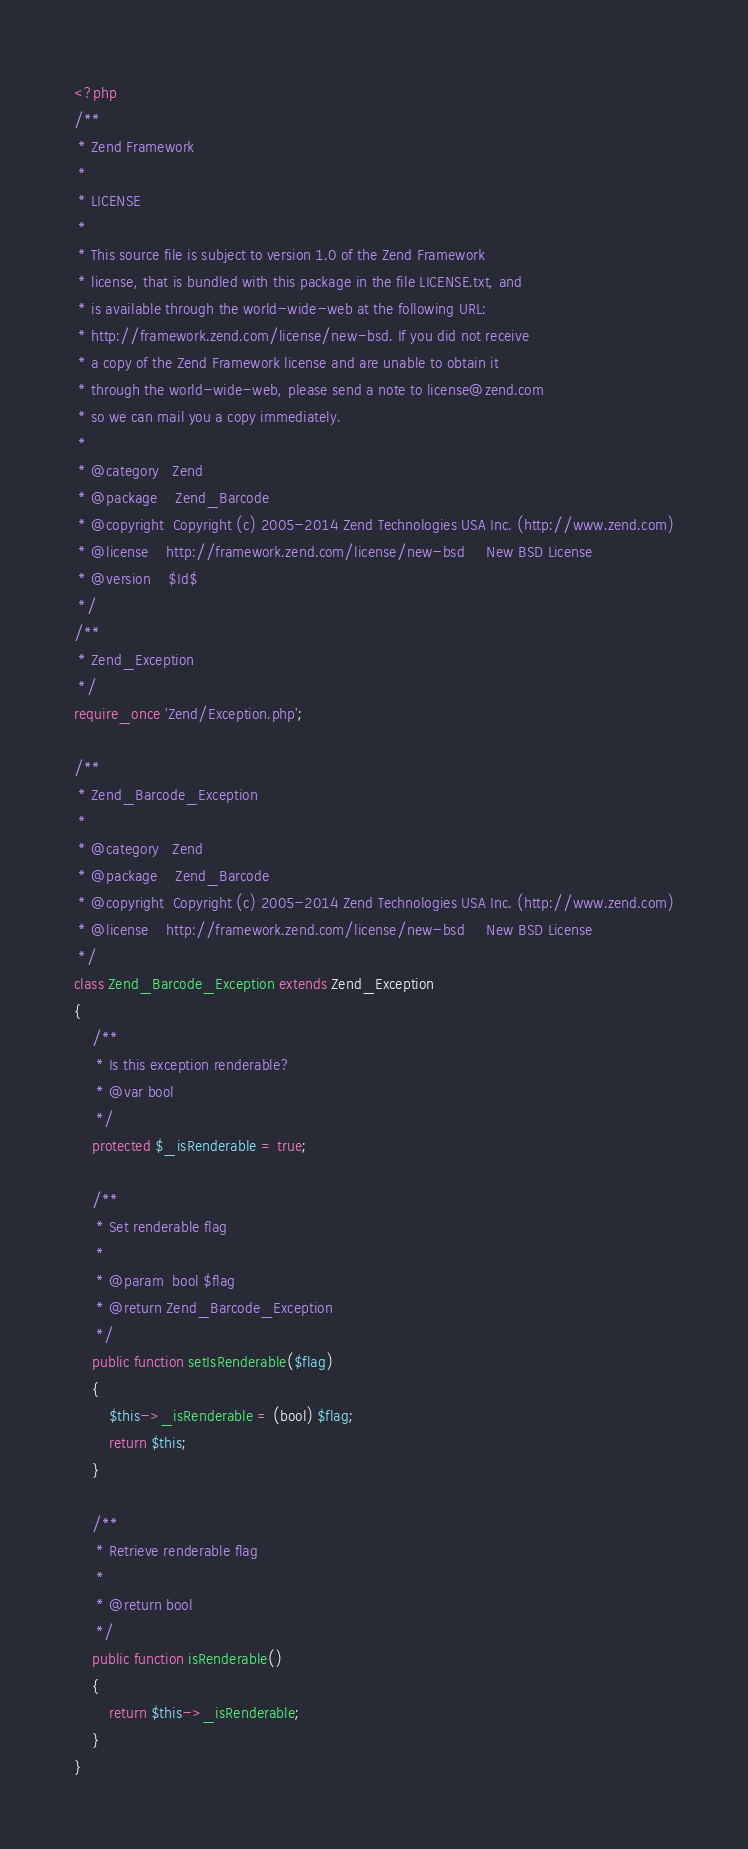Convert code to text. <code><loc_0><loc_0><loc_500><loc_500><_PHP_><?php
/**
 * Zend Framework
 *
 * LICENSE
 *
 * This source file is subject to version 1.0 of the Zend Framework
 * license, that is bundled with this package in the file LICENSE.txt, and
 * is available through the world-wide-web at the following URL:
 * http://framework.zend.com/license/new-bsd. If you did not receive
 * a copy of the Zend Framework license and are unable to obtain it
 * through the world-wide-web, please send a note to license@zend.com
 * so we can mail you a copy immediately.
 *
 * @category   Zend
 * @package    Zend_Barcode
 * @copyright  Copyright (c) 2005-2014 Zend Technologies USA Inc. (http://www.zend.com)
 * @license    http://framework.zend.com/license/new-bsd     New BSD License
 * @version    $Id$
 */
/**
 * Zend_Exception
 */
require_once 'Zend/Exception.php';

/**
 * Zend_Barcode_Exception
 *
 * @category   Zend
 * @package    Zend_Barcode
 * @copyright  Copyright (c) 2005-2014 Zend Technologies USA Inc. (http://www.zend.com)
 * @license    http://framework.zend.com/license/new-bsd     New BSD License
 */
class Zend_Barcode_Exception extends Zend_Exception
{
    /**
     * Is this exception renderable?
     * @var bool
     */
    protected $_isRenderable = true;

    /**
     * Set renderable flag
     *
     * @param  bool $flag
     * @return Zend_Barcode_Exception
     */
    public function setIsRenderable($flag)
    {
        $this->_isRenderable = (bool) $flag;
        return $this;
    }

    /**
     * Retrieve renderable flag
     *
     * @return bool
     */
    public function isRenderable()
    {
        return $this->_isRenderable;
    }
}
</code> 